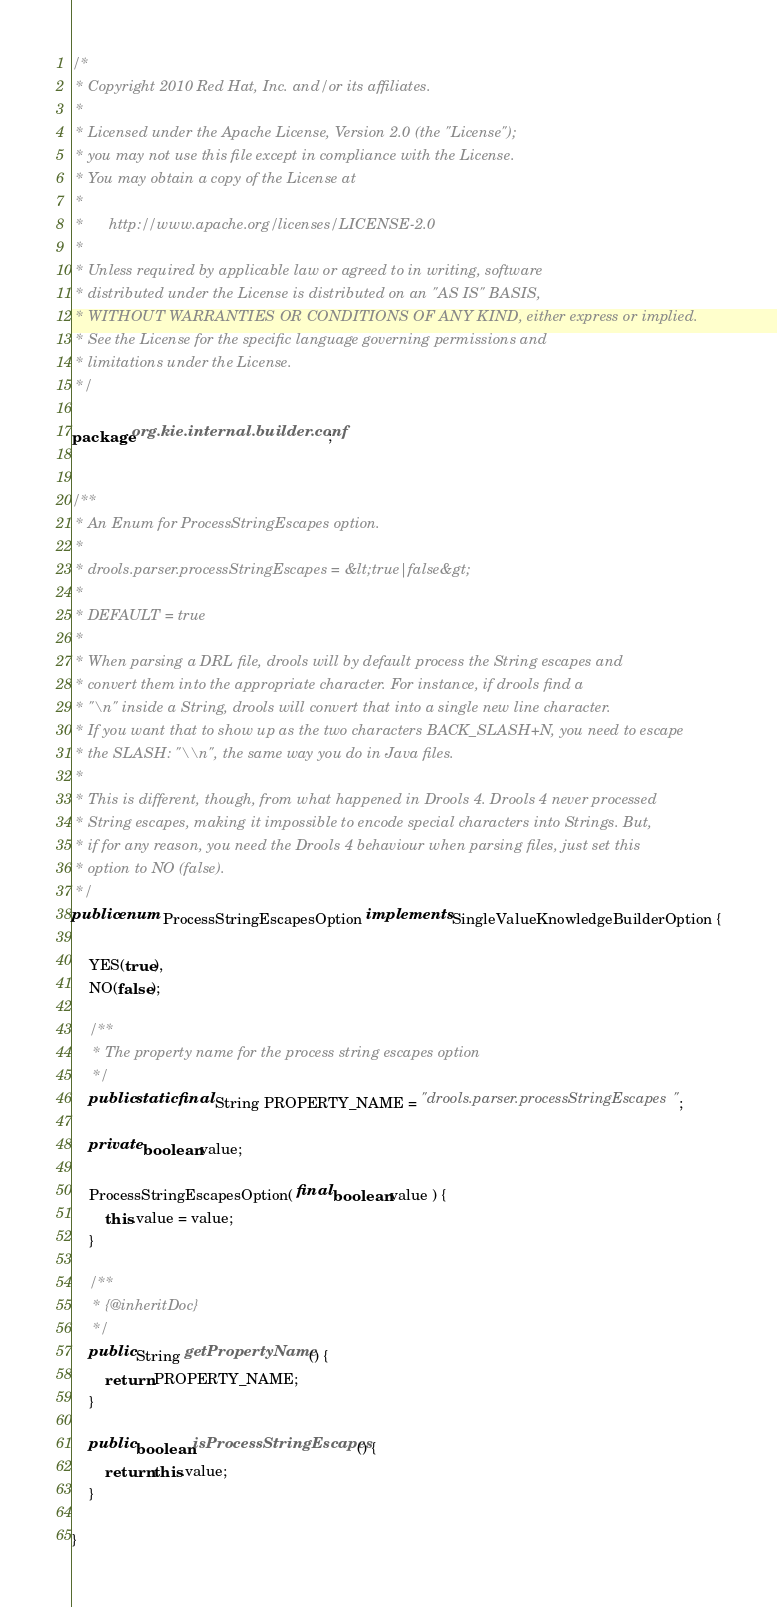<code> <loc_0><loc_0><loc_500><loc_500><_Java_>/*
 * Copyright 2010 Red Hat, Inc. and/or its affiliates.
 *
 * Licensed under the Apache License, Version 2.0 (the "License");
 * you may not use this file except in compliance with the License.
 * You may obtain a copy of the License at
 *
 *      http://www.apache.org/licenses/LICENSE-2.0
 *
 * Unless required by applicable law or agreed to in writing, software
 * distributed under the License is distributed on an "AS IS" BASIS,
 * WITHOUT WARRANTIES OR CONDITIONS OF ANY KIND, either express or implied.
 * See the License for the specific language governing permissions and
 * limitations under the License.
 */

package org.kie.internal.builder.conf;


/**
 * An Enum for ProcessStringEscapes option.
 *
 * drools.parser.processStringEscapes = &lt;true|false&gt;
 *
 * DEFAULT = true
 *
 * When parsing a DRL file, drools will by default process the String escapes and
 * convert them into the appropriate character. For instance, if drools find a
 * "\n" inside a String, drools will convert that into a single new line character.
 * If you want that to show up as the two characters BACK_SLASH+N, you need to escape
 * the SLASH: "\\n", the same way you do in Java files.
 *
 * This is different, though, from what happened in Drools 4. Drools 4 never processed
 * String escapes, making it impossible to encode special characters into Strings. But,
 * if for any reason, you need the Drools 4 behaviour when parsing files, just set this
 * option to NO (false).
 */
public enum ProcessStringEscapesOption implements SingleValueKnowledgeBuilderOption {

    YES(true),
    NO(false);

    /**
     * The property name for the process string escapes option
     */
    public static final String PROPERTY_NAME = "drools.parser.processStringEscapes";

    private boolean value;

    ProcessStringEscapesOption( final boolean value ) {
        this.value = value;
    }

    /**
     * {@inheritDoc}
     */
    public String getPropertyName() {
        return PROPERTY_NAME;
    }

    public boolean isProcessStringEscapes() {
        return this.value;
    }

}
</code> 